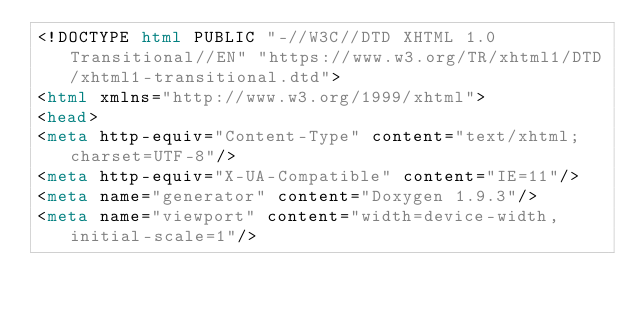<code> <loc_0><loc_0><loc_500><loc_500><_HTML_><!DOCTYPE html PUBLIC "-//W3C//DTD XHTML 1.0 Transitional//EN" "https://www.w3.org/TR/xhtml1/DTD/xhtml1-transitional.dtd">
<html xmlns="http://www.w3.org/1999/xhtml">
<head>
<meta http-equiv="Content-Type" content="text/xhtml;charset=UTF-8"/>
<meta http-equiv="X-UA-Compatible" content="IE=11"/>
<meta name="generator" content="Doxygen 1.9.3"/>
<meta name="viewport" content="width=device-width, initial-scale=1"/></code> 